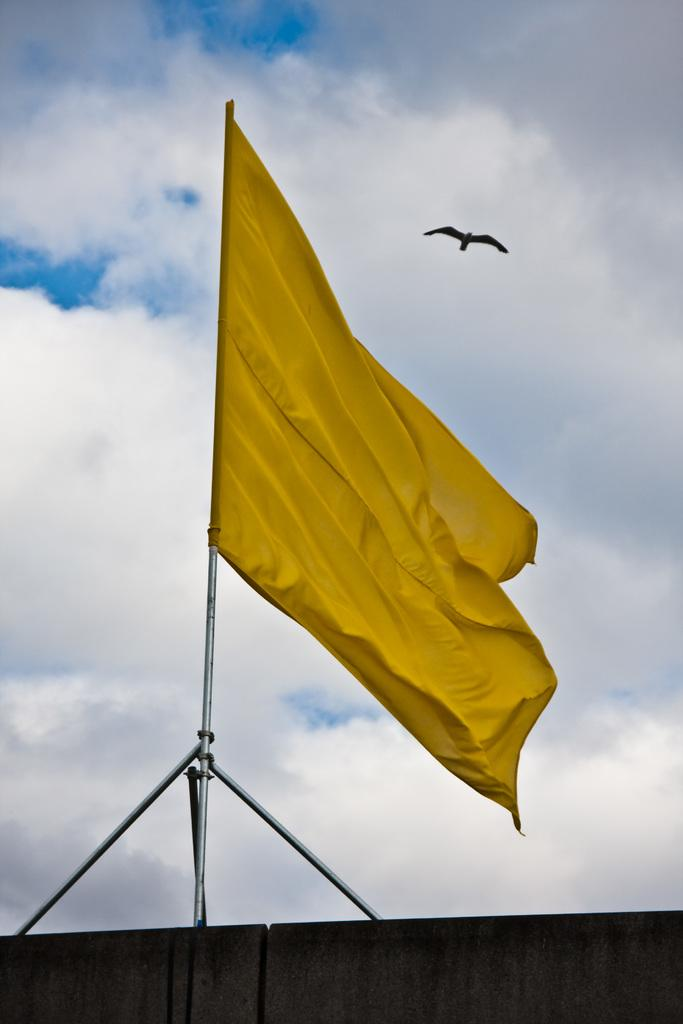What color is the flag in the image? The flag in the image is yellow. What can be seen in the background of the image? There is a bird visible in the background of the image. What colors are present in the sky in the image? The sky is blue and white in color. What type of celery is being used as a bookmark in the image? There is no celery or book present in the image. 